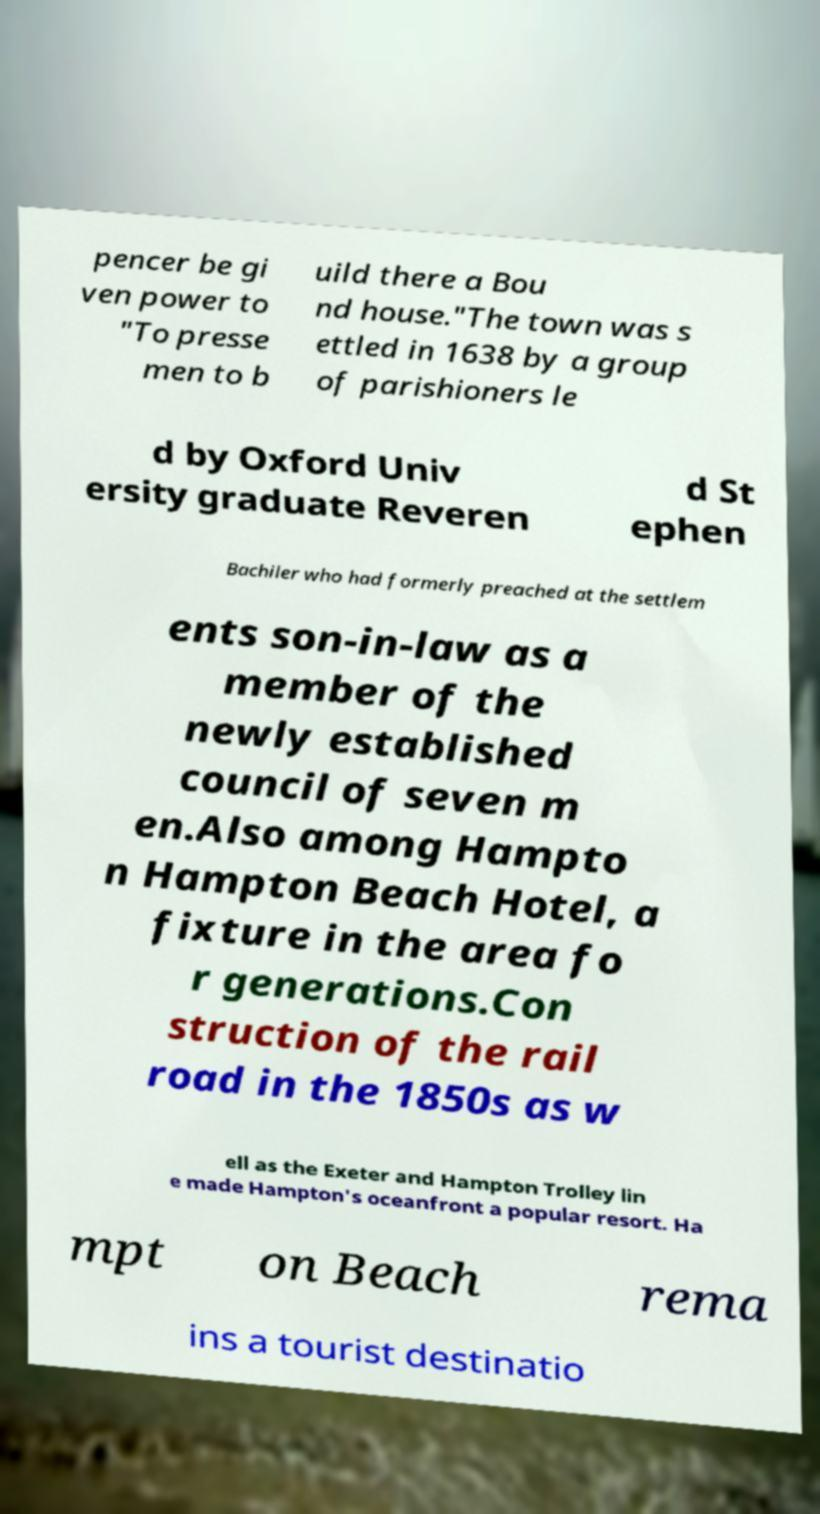There's text embedded in this image that I need extracted. Can you transcribe it verbatim? pencer be gi ven power to "To presse men to b uild there a Bou nd house."The town was s ettled in 1638 by a group of parishioners le d by Oxford Univ ersity graduate Reveren d St ephen Bachiler who had formerly preached at the settlem ents son-in-law as a member of the newly established council of seven m en.Also among Hampto n Hampton Beach Hotel, a fixture in the area fo r generations.Con struction of the rail road in the 1850s as w ell as the Exeter and Hampton Trolley lin e made Hampton's oceanfront a popular resort. Ha mpt on Beach rema ins a tourist destinatio 